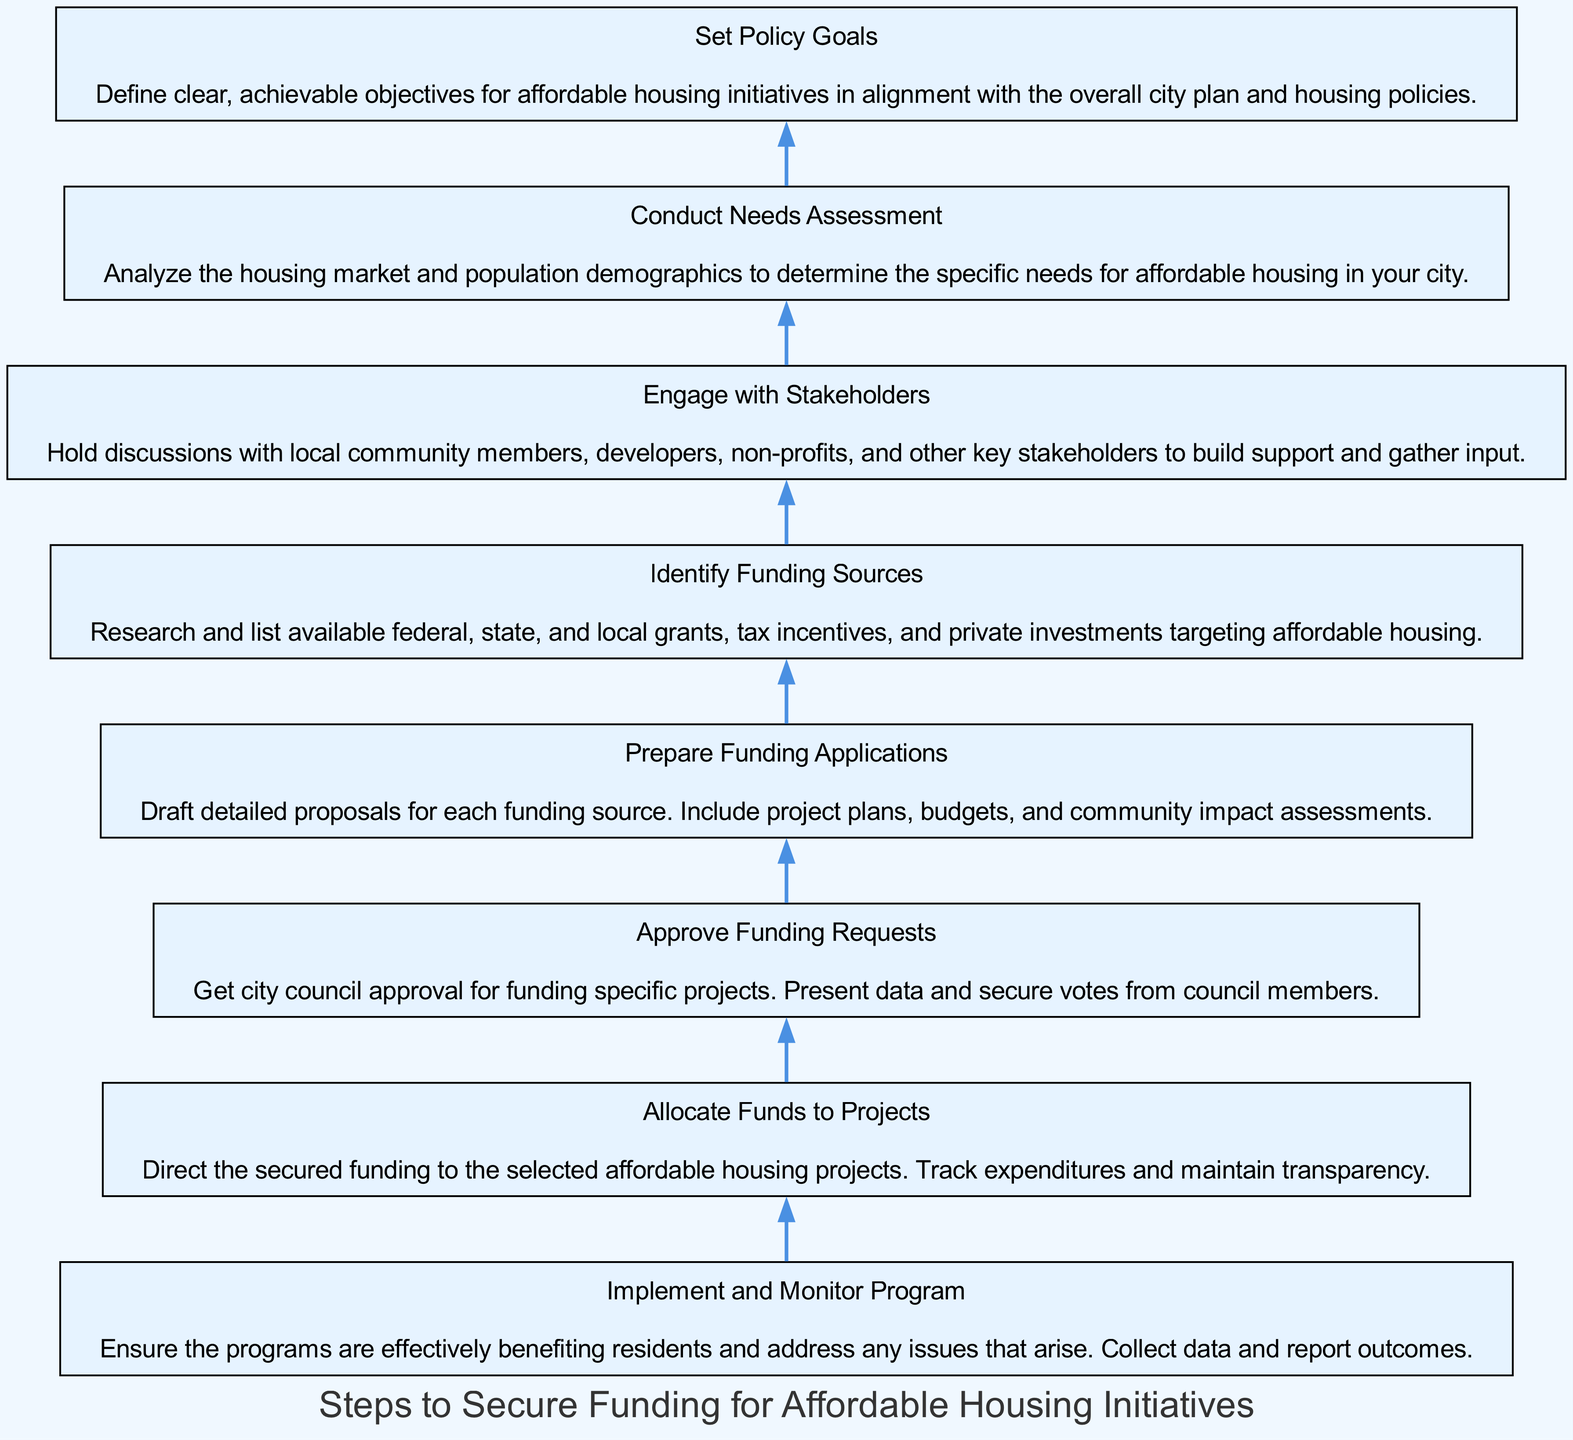What is the final step in the diagram? The final step shown in the diagram is "Implement and Monitor Program". It is positioned at the top as the concluding part of the process, following all prior steps.
Answer: Implement and Monitor Program How many steps are there in total? The diagram contains a total of eight steps, as listed in the provided data.
Answer: 8 Which step directly precedes "Allocate Funds to Projects"? "Approve Funding Requests" is directly before "Allocate Funds to Projects", indicating the sequence of the process where funding must be approved before allocation.
Answer: Approve Funding Requests What action is taken before preparing funding applications? The action taken before preparing funding applications is "Identify Funding Sources". This establishes the foundation for the proposals that will be drafted.
Answer: Identify Funding Sources What do the stakeholders need to do in advance of setting policy goals? "Engage with Stakeholders" must take place before setting policy goals, as this step is crucial for building support and understanding community needs.
Answer: Engage with Stakeholders What is the purpose of the "Conduct Needs Assessment" step? The purpose of "Conduct Needs Assessment" is to analyze housing needs in the city, ensuring that the subsequent steps are informed by actual data and community demographics.
Answer: Analyze the housing market Which step requires city council approval? The step that requires city council approval is "Approve Funding Requests", as it involves getting the necessary votes for funding decisions.
Answer: Approve Funding Requests How does "Set Policy Goals" relate to previous steps? "Set Policy Goals" is linked to earlier steps as it is based on the data and insights gathered from "Conduct Needs Assessment" and the engagement with stakeholders, ensuring alignment with city policies.
Answer: It is based on earlier assessments 